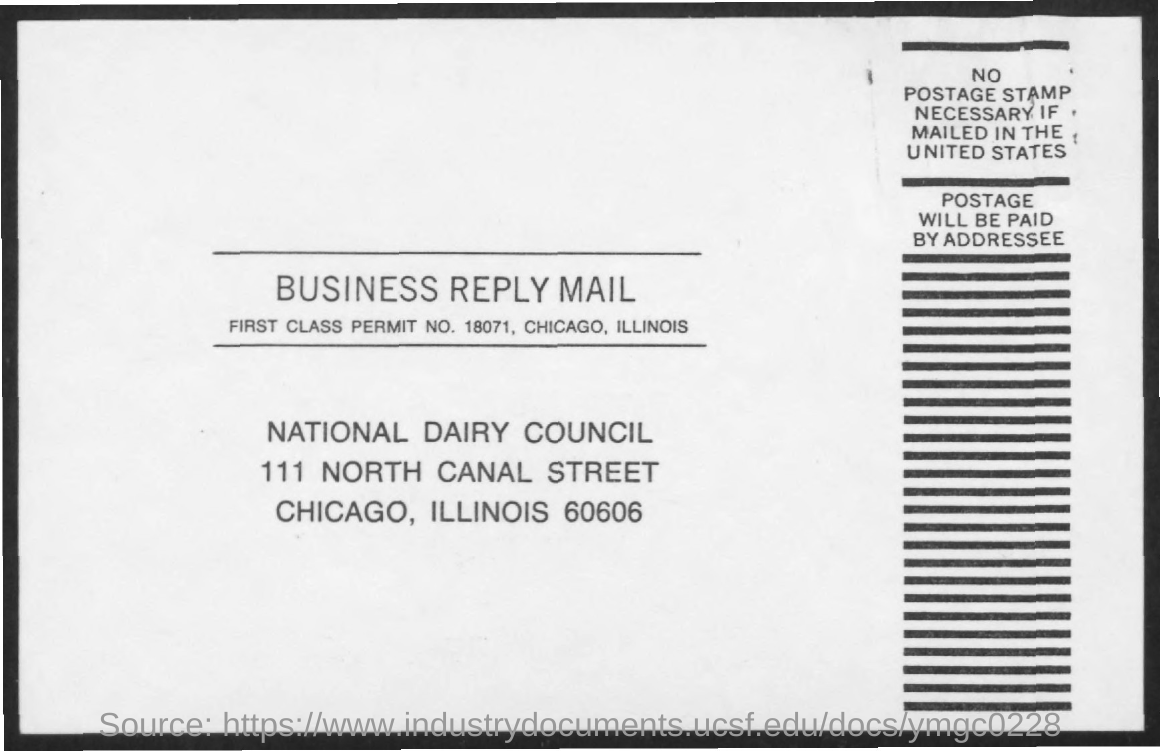Draw attention to some important aspects in this diagram. The first class permit number mentioned in the business reply mail is 18071. 